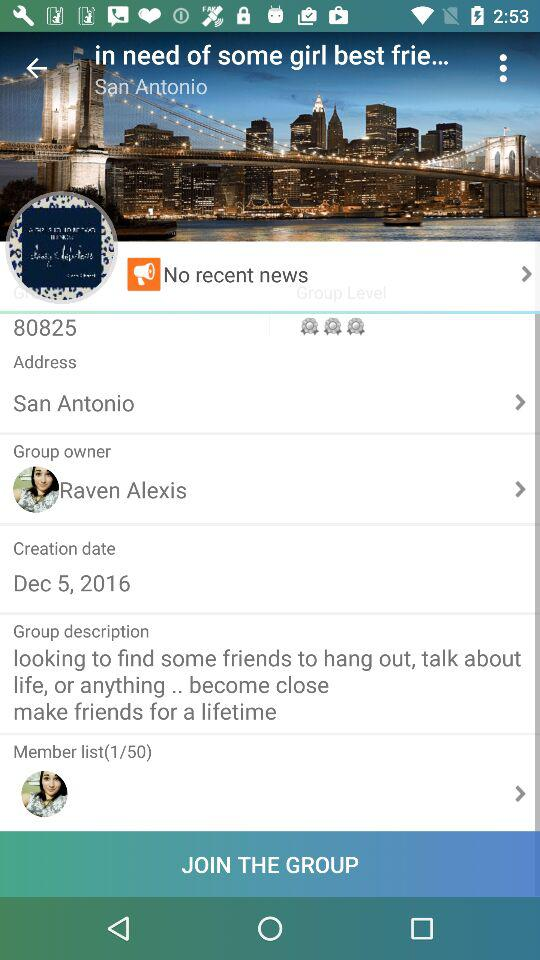What is the creation date? The creation date is 5 December, 2016. 